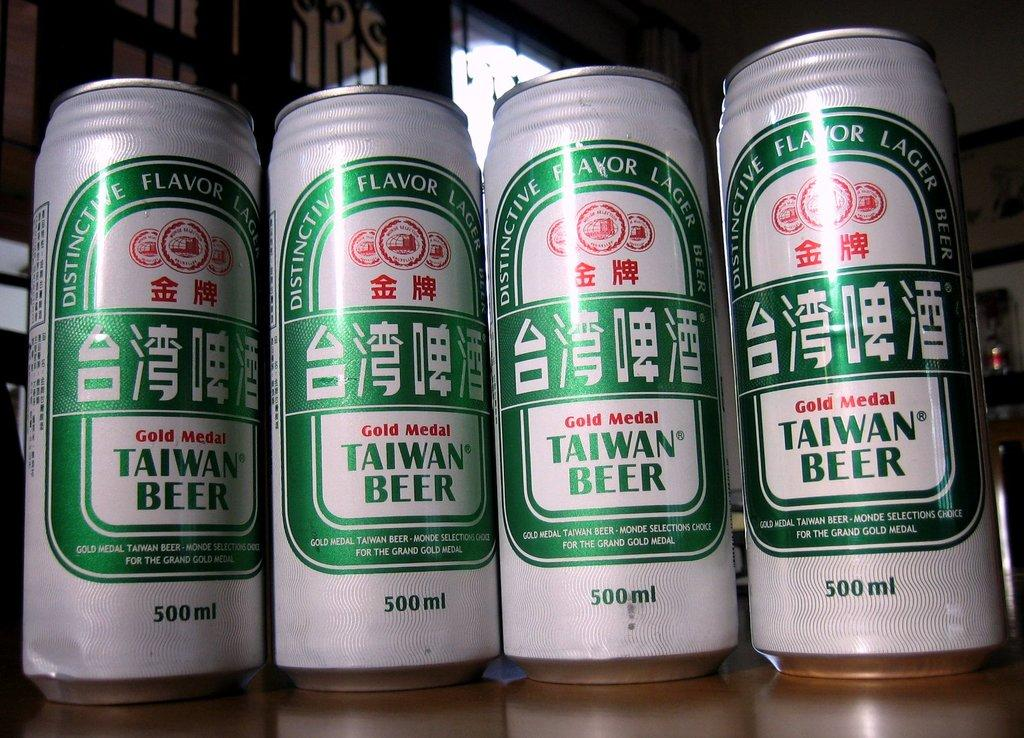<image>
Describe the image concisely. Four cans of Taiwan beer are sitting on a table. 